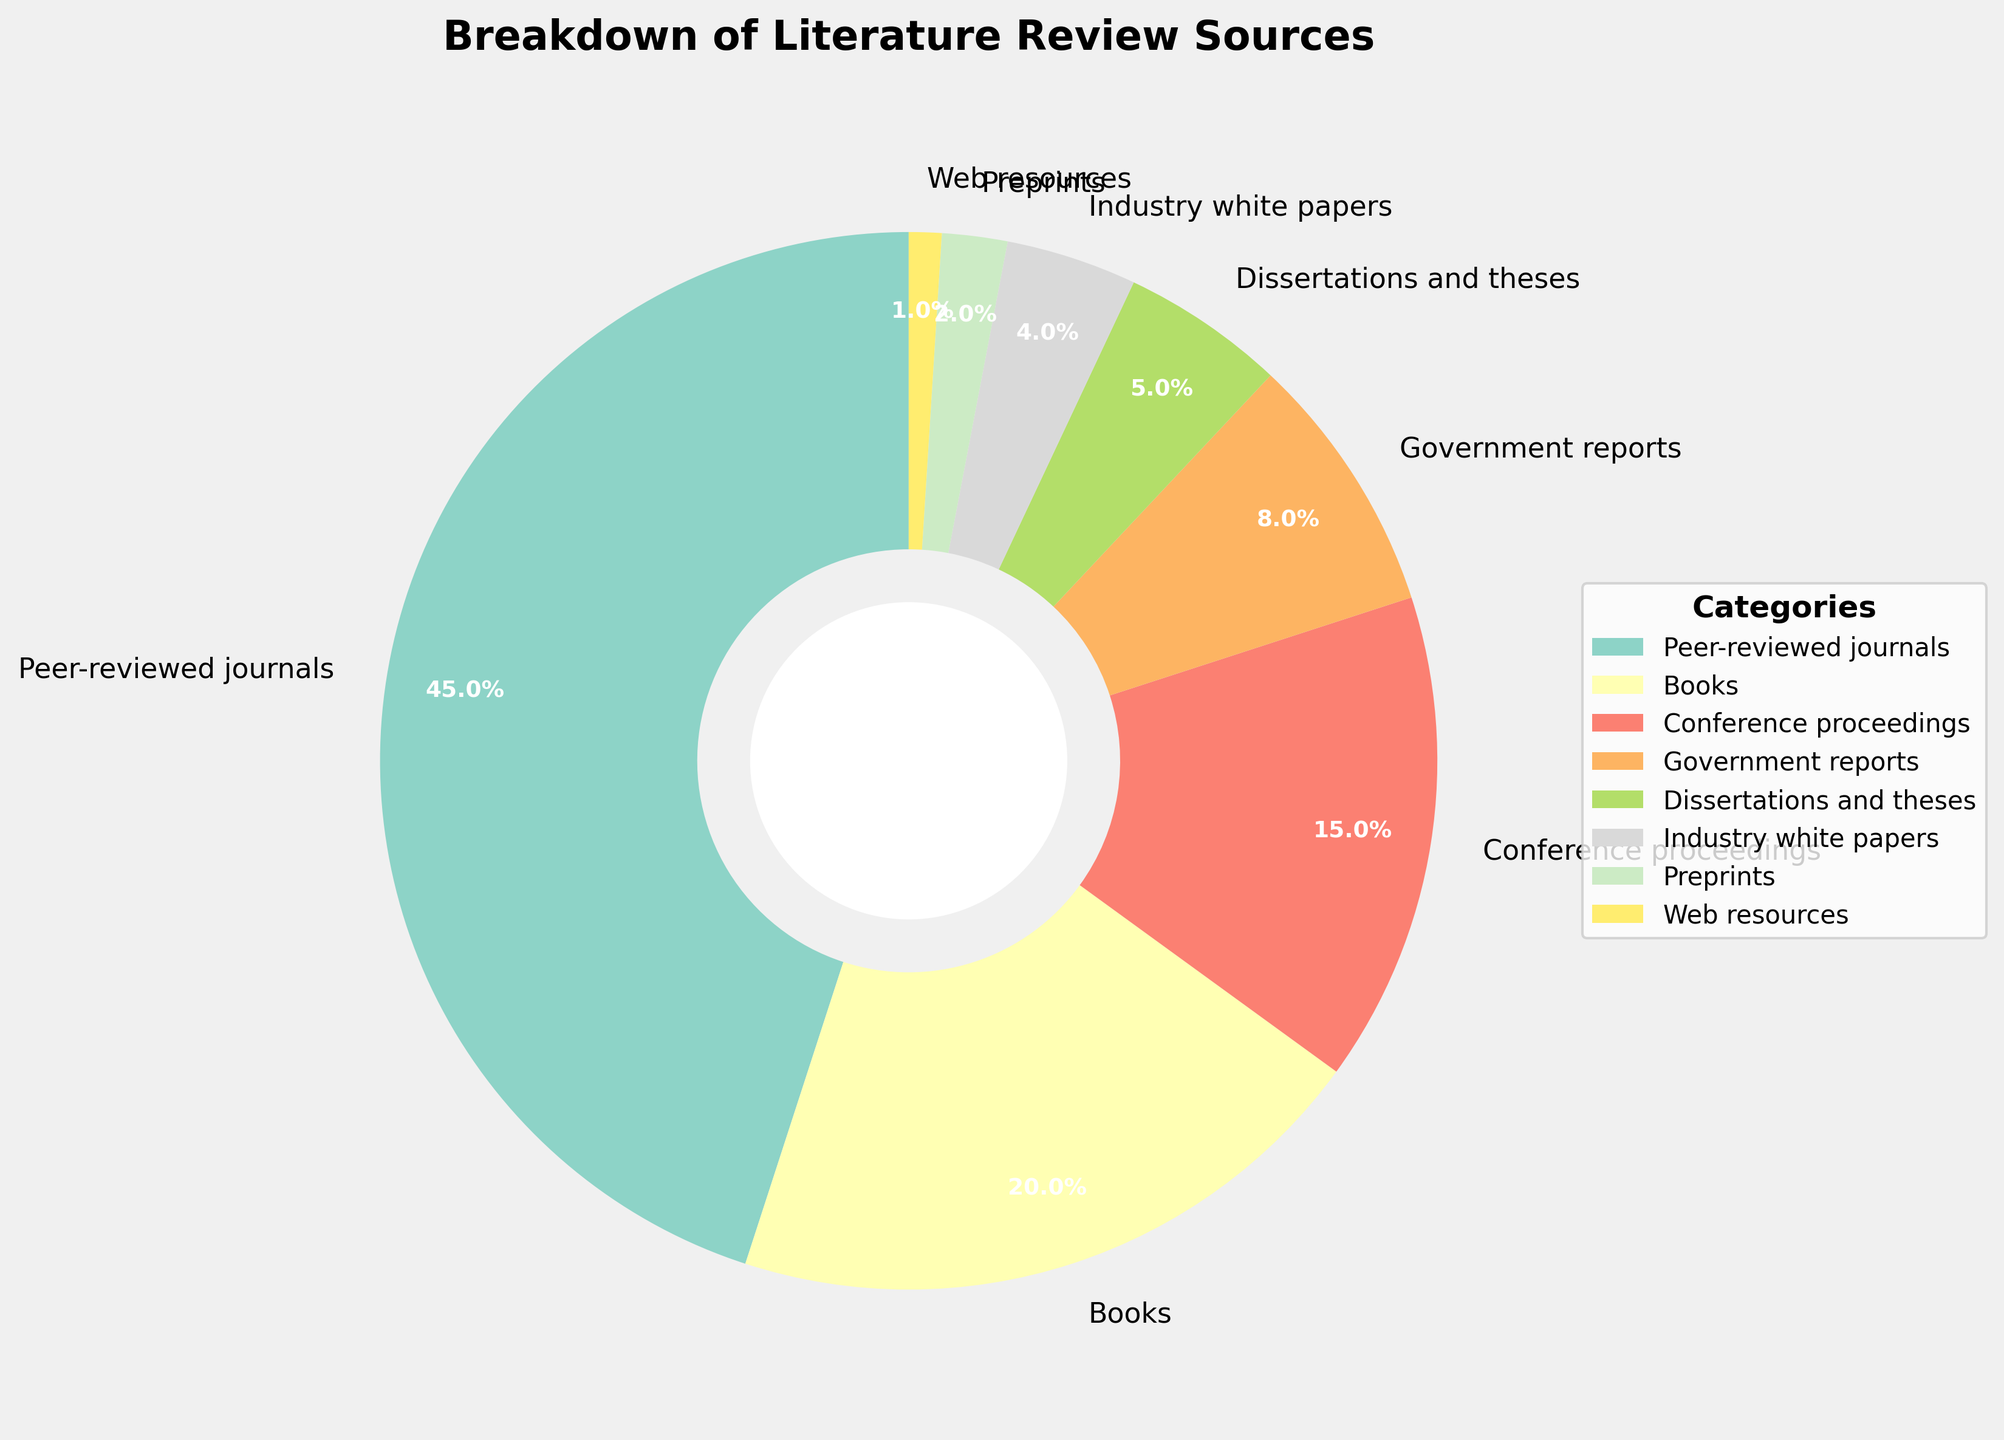What percentage of the sources does the largest category represent? The largest category in the pie chart is "Peer-reviewed journals" as visually it takes up the most space. The percentage next to it indicates 45%.
Answer: 45% Which two categories combined account for more than half of the sources? To see which categories combined account for more than 50%, we start by identifying the largest ones. "Peer-reviewed journals" (45%) and "Books" (20%) together account for 45% + 20% = 65%, which is more than half.
Answer: Peer-reviewed journals and Books What percentage do "Industry white papers" and "Government reports" categories combine to? "Industry white papers" contribute 4% and "Government reports" contribute 8%. So, combined, they contribute 4% + 8% = 12%.
Answer: 12% Which category contributes the least to the literature review sources? The category with the smallest slice in the pie chart is marked as "Web resources" with a percentage of 1%.
Answer: Web resources In terms of visual representation, which categories are represented by the smallest and largest wedges, and what are their corresponding percentages? The largest wedge represents "Peer-reviewed journals" at 45%, and the smallest wedge represents "Web resources" at 1%, as seen from their segment sizes.
Answer: Peer-reviewed journals (45%) and Web resources (1%) How do the percentages of "Conference proceedings" and "Dissertations and theses" compare? In the pie chart, "Conference proceedings" account for 15%, while "Dissertations and theses" account for 5%, making "Conference proceedings" 10% higher than "Dissertations and theses".
Answer: Conference proceedings are 10% higher Arrange the categories in descending order based on their contribution. According to the pie chart, the descending order based on contribution percentages are: Peer-reviewed journals (45%), Books (20%), Conference proceedings (15%), Government reports (8%), Dissertations and theses (5%), Industry white papers (4%), Preprints (2%), Web resources (1%).
Answer: Peer-reviewed journals, Books, Conference proceedings, Government reports, Dissertations and theses, Industry white papers, Preprints, Web resources What's the cumulative percentage of the three smallest categories? The three smallest categories by percentage are "Web resources" (1%), "Preprints" (2%), and "Industry white papers" (4%). Their cumulative percentage is 1% + 2% + 4% = 7%.
Answer: 7% Which category is twice as large as "Government reports"? "Government reports" account for 8%. The category twice as large would be 8% * 2 = 16%. "Conference proceedings" at 15% is closest but slightly less. *No category is exactly twice, so none*.
Answer: None 